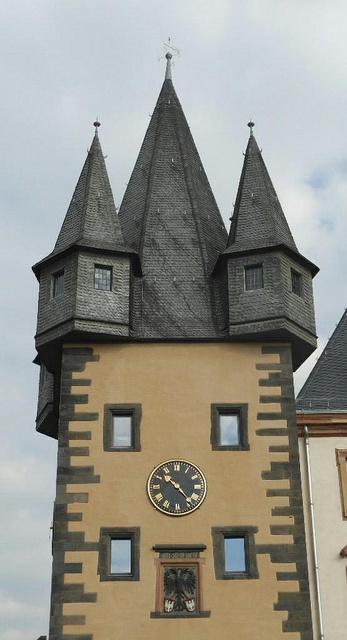Describe the objects in this image and their specific colors. I can see a clock in lightgray, gray, darkgreen, darkgray, and black tones in this image. 